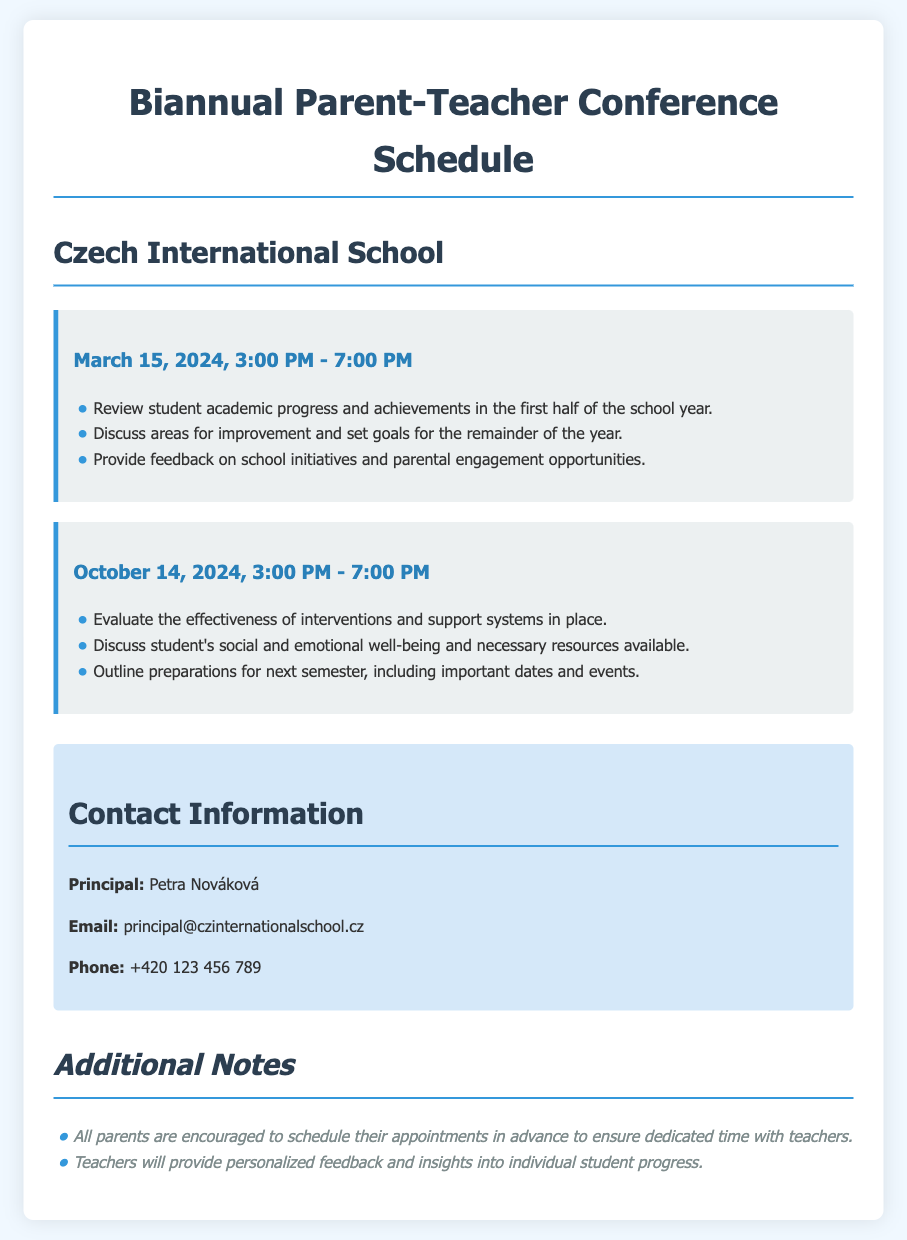What is the date and time of the first conference? The first conference is scheduled for March 15, 2024, from 3:00 PM to 7:00 PM.
Answer: March 15, 2024, 3:00 PM - 7:00 PM What is one topic to be discussed during the first conference? The first conference will review student academic progress and achievements in the first half of the school year.
Answer: Review student academic progress Who is the principal of the school? The principal's name is provided in the contact information section of the document.
Answer: Petra Nováková What is the purpose of the October 14, 2024 conference? The second conference focuses on evaluating interventions and discussing social and emotional well-being.
Answer: Evaluate the effectiveness of interventions How many specific objectives are mentioned for the October conference? The document lists three objectives for the October conference.
Answer: Three What should parents do in advance of the conferences? The document encourages parents to schedule their appointments in advance.
Answer: Schedule their appointments What is the phone number of the principal? The contact section includes the principal's phone number.
Answer: +420 123 456 789 What is one key aspect of the parental engagement during the conferences? The document mentions providing feedback on school initiatives and parental engagement opportunities.
Answer: Feedback on school initiatives 